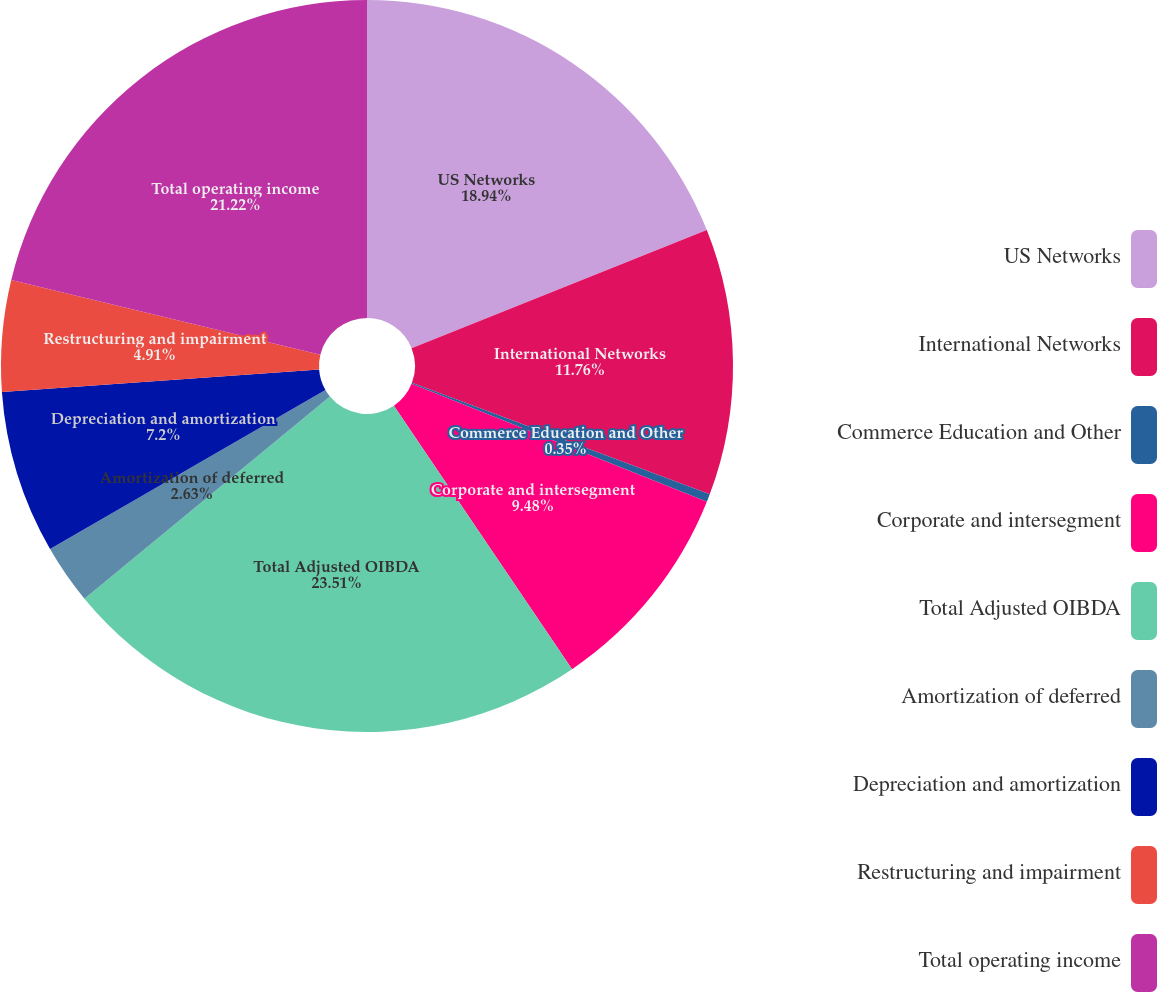<chart> <loc_0><loc_0><loc_500><loc_500><pie_chart><fcel>US Networks<fcel>International Networks<fcel>Commerce Education and Other<fcel>Corporate and intersegment<fcel>Total Adjusted OIBDA<fcel>Amortization of deferred<fcel>Depreciation and amortization<fcel>Restructuring and impairment<fcel>Total operating income<nl><fcel>18.94%<fcel>11.76%<fcel>0.35%<fcel>9.48%<fcel>23.5%<fcel>2.63%<fcel>7.2%<fcel>4.91%<fcel>21.22%<nl></chart> 